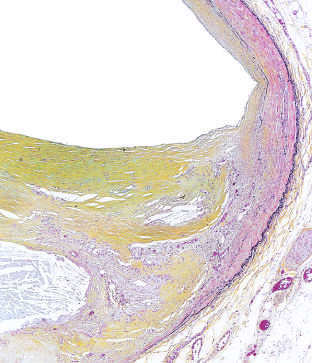what are attenuated?
Answer the question using a single word or phrase. The internal and external elastic membranes 